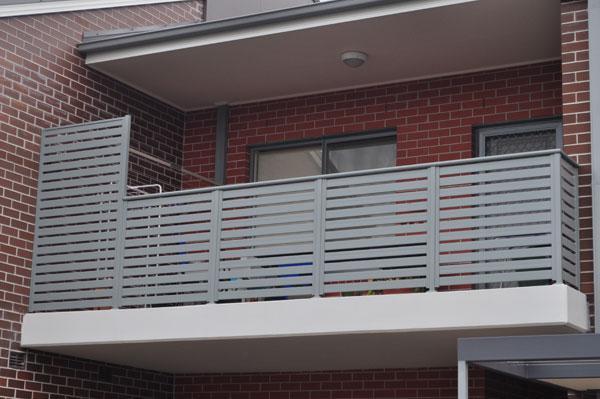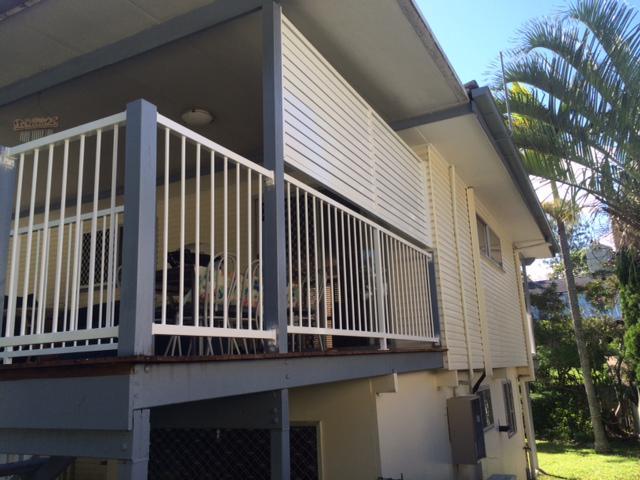The first image is the image on the left, the second image is the image on the right. Examine the images to the left and right. Is the description "The balcony in the left image has close-together horizontal boards for rails, and the balcony on the right has vertical white bars for rails." accurate? Answer yes or no. Yes. 